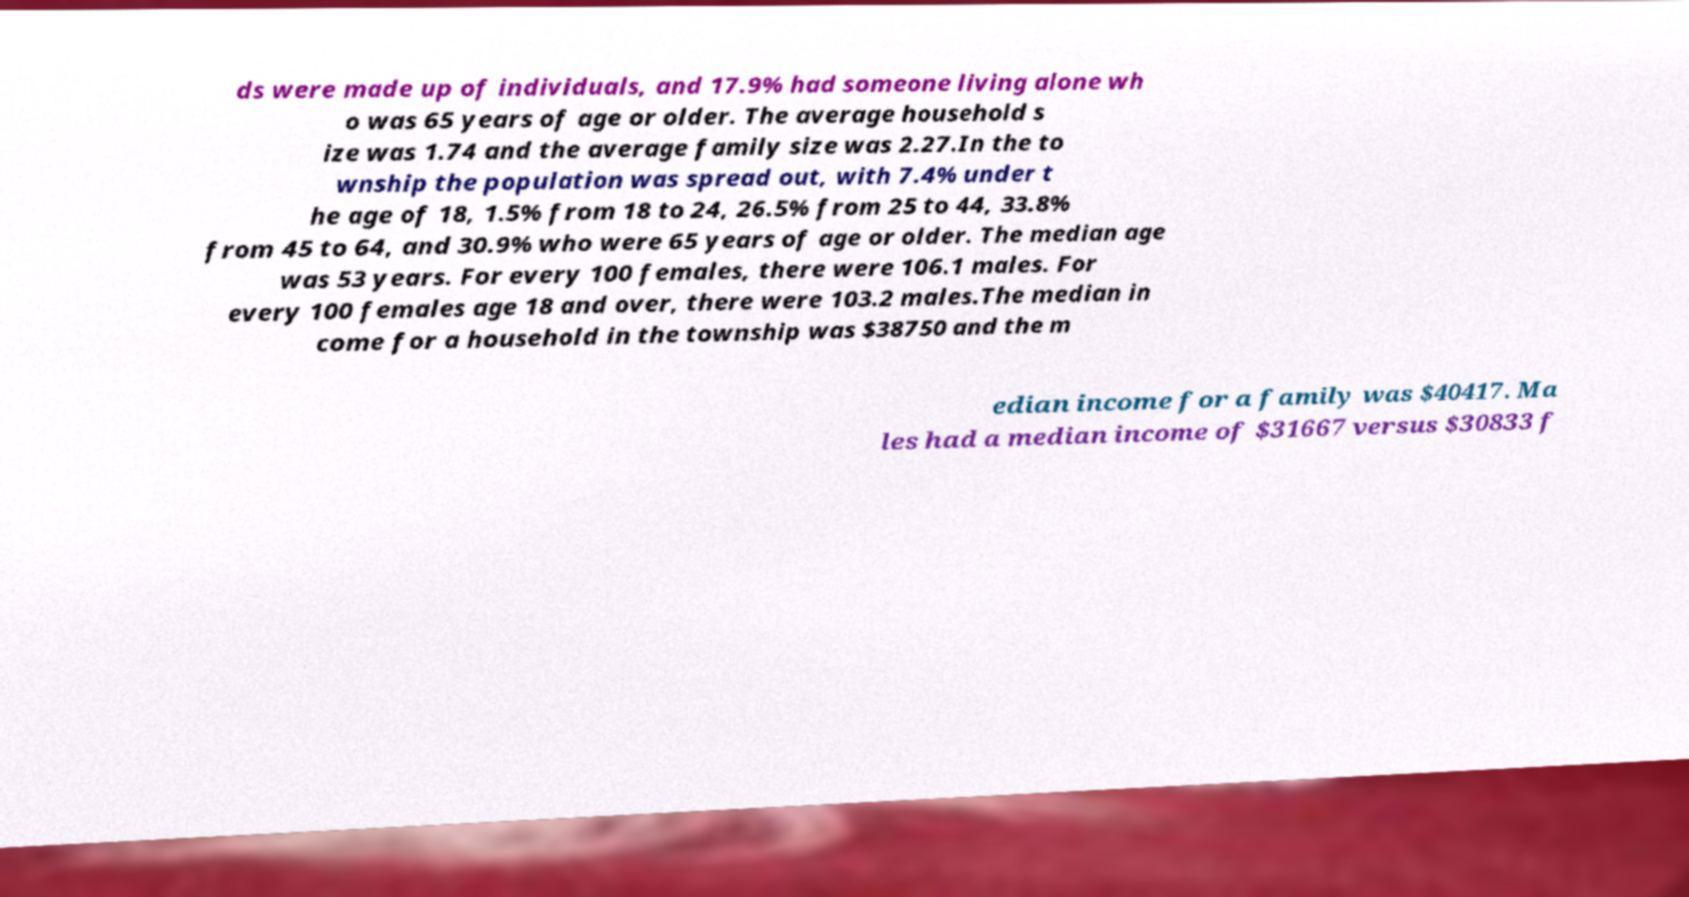Please identify and transcribe the text found in this image. ds were made up of individuals, and 17.9% had someone living alone wh o was 65 years of age or older. The average household s ize was 1.74 and the average family size was 2.27.In the to wnship the population was spread out, with 7.4% under t he age of 18, 1.5% from 18 to 24, 26.5% from 25 to 44, 33.8% from 45 to 64, and 30.9% who were 65 years of age or older. The median age was 53 years. For every 100 females, there were 106.1 males. For every 100 females age 18 and over, there were 103.2 males.The median in come for a household in the township was $38750 and the m edian income for a family was $40417. Ma les had a median income of $31667 versus $30833 f 